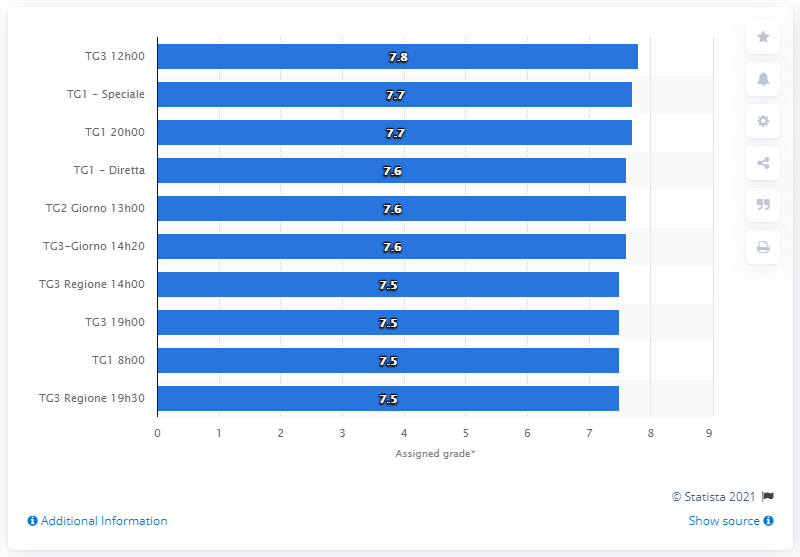Indicate a few pertinent items in this graphic. The grade that TG3 received out of ten was 7.8. 